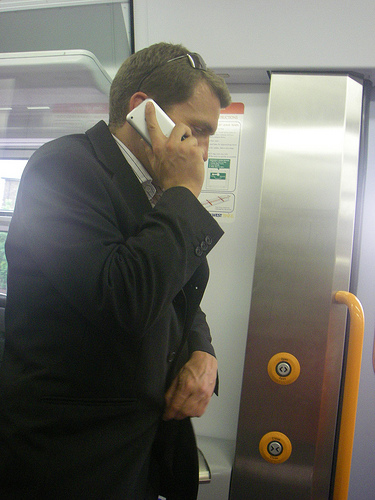If you could imagine a backstory for this man, what would it be? This man could be a business professional on his way to an important meeting. Early morning, he is already on his phone handling work calls, reflecting a busy lifestyle. In his jacket and formal attire, he might be discussing last-minute details or setting up appointments for the day. 